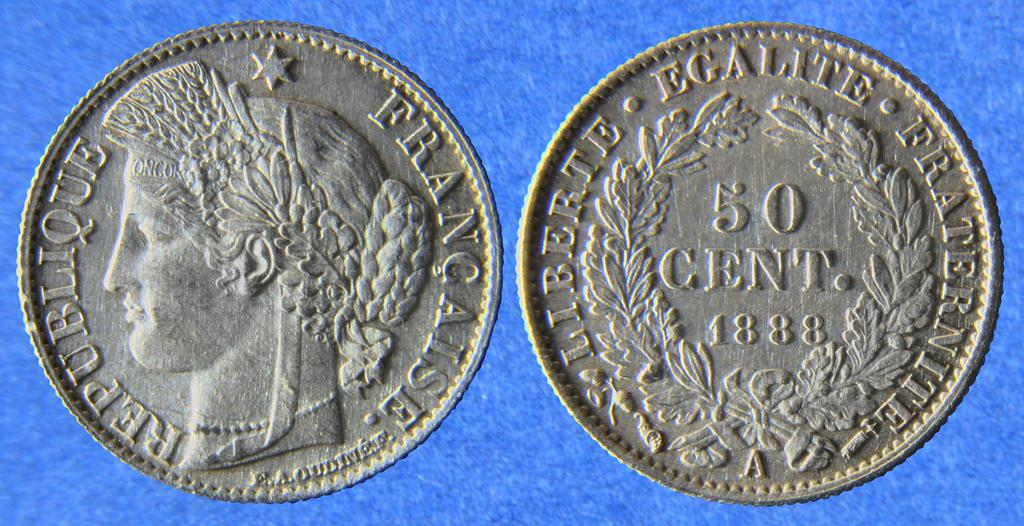<image>
Render a clear and concise summary of the photo. A coin from 1888 says 50 cents from France. 